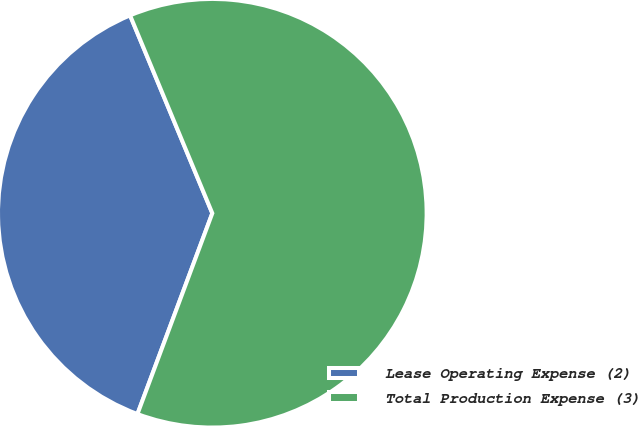<chart> <loc_0><loc_0><loc_500><loc_500><pie_chart><fcel>Lease Operating Expense (2)<fcel>Total Production Expense (3)<nl><fcel>38.05%<fcel>61.95%<nl></chart> 